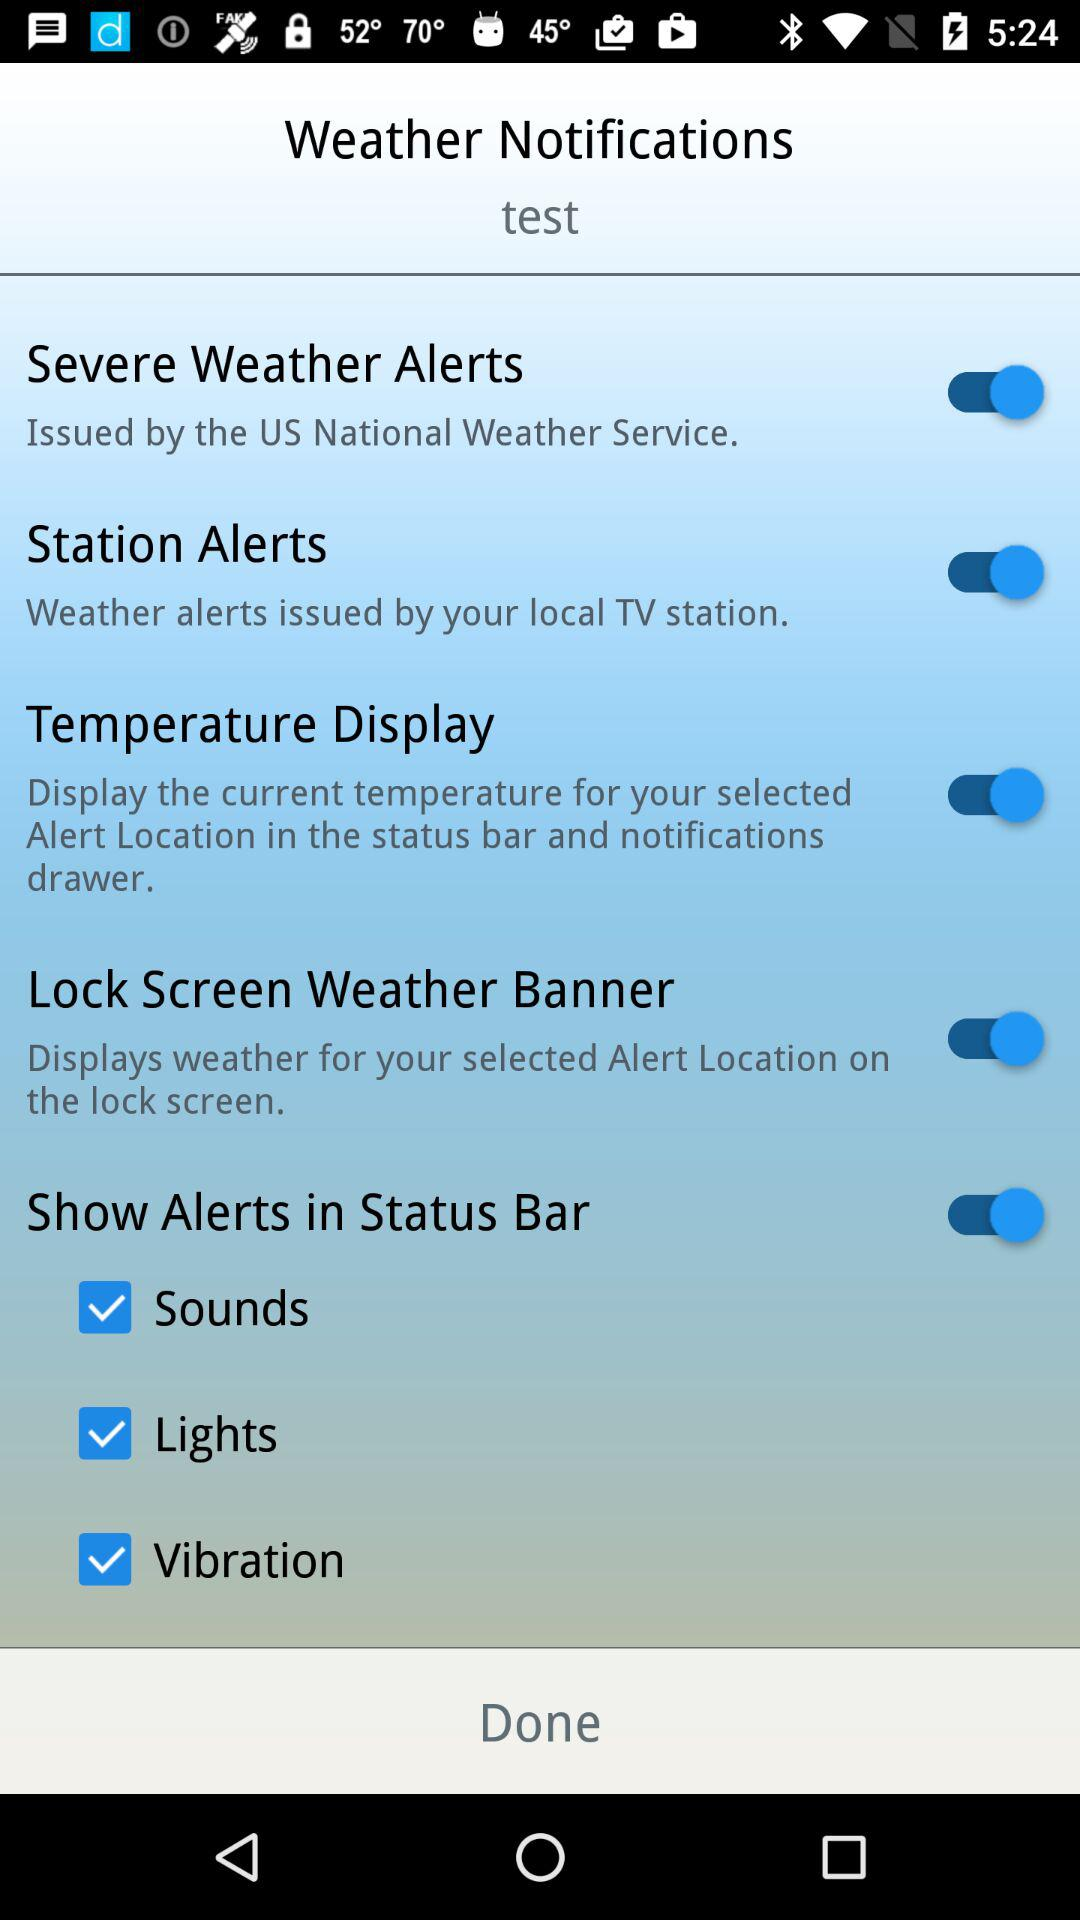What's the status of "Station Alerts"? The status is "on". 